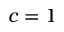Convert formula to latex. <formula><loc_0><loc_0><loc_500><loc_500>c = 1</formula> 